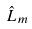<formula> <loc_0><loc_0><loc_500><loc_500>\hat { L } _ { m }</formula> 